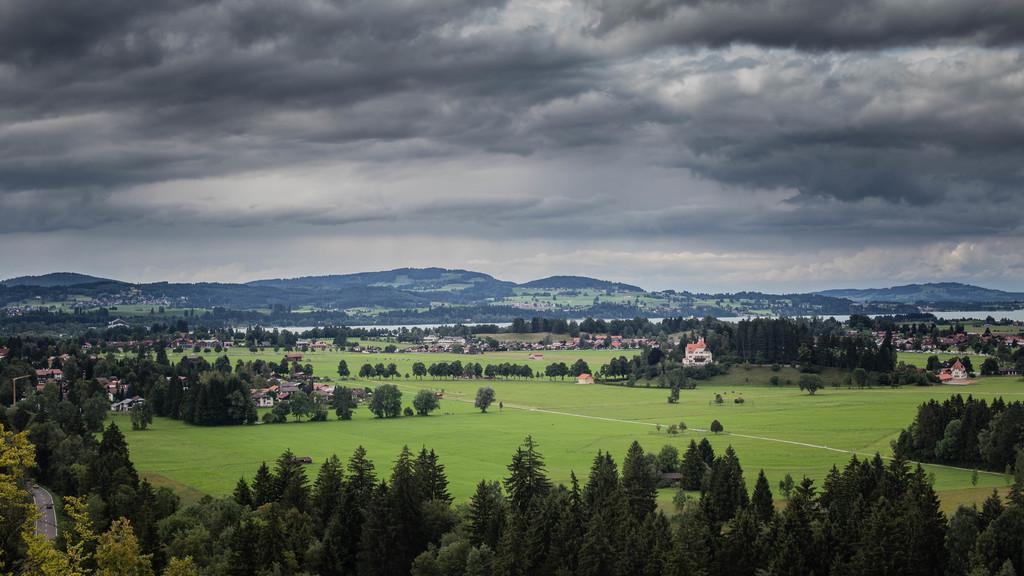Please provide a concise description of this image. In this image we can see there are some trees, houses, grass, water and mountains, in the background we can see the sky with clouds. 